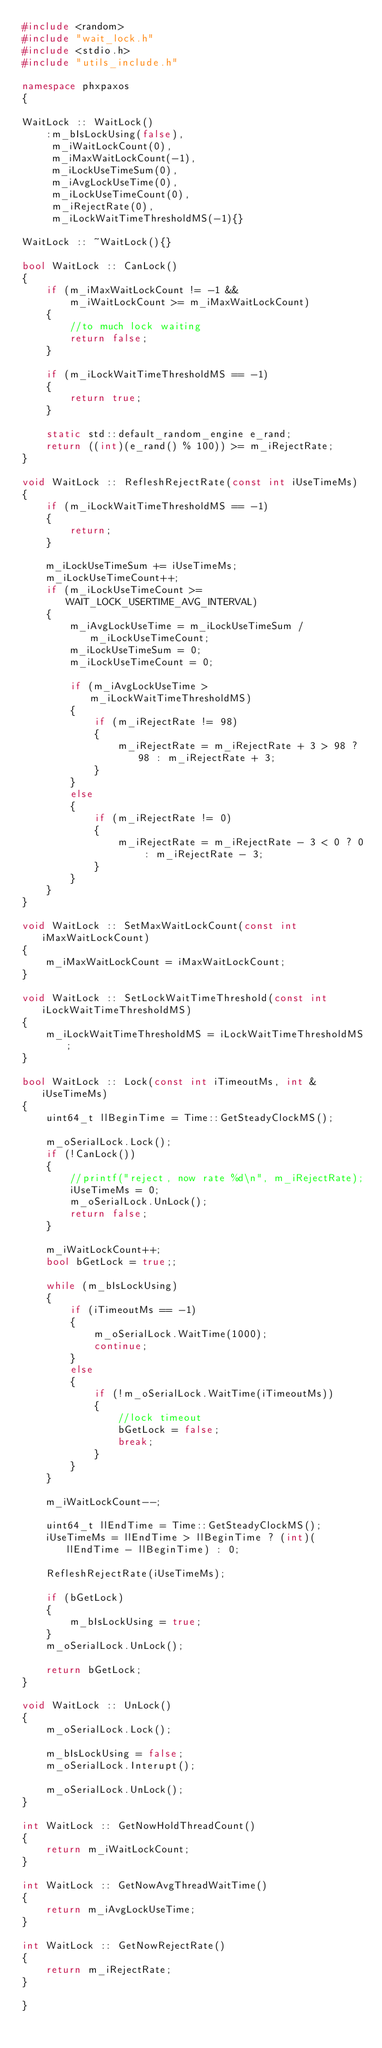Convert code to text. <code><loc_0><loc_0><loc_500><loc_500><_C++_>#include <random>
#include "wait_lock.h"
#include <stdio.h>
#include "utils_include.h"

namespace phxpaxos
{

WaitLock :: WaitLock() 
    :m_bIsLockUsing(false),
     m_iWaitLockCount(0),
     m_iMaxWaitLockCount(-1),
     m_iLockUseTimeSum(0),
     m_iAvgLockUseTime(0),
     m_iLockUseTimeCount(0),
     m_iRejectRate(0),
     m_iLockWaitTimeThresholdMS(-1){}

WaitLock :: ~WaitLock(){}

bool WaitLock :: CanLock()
{
    if (m_iMaxWaitLockCount != -1 &&
        m_iWaitLockCount >= m_iMaxWaitLockCount) 
    {
        //to much lock waiting
        return false;
    }

    if (m_iLockWaitTimeThresholdMS == -1)
    {
        return true;
    }

    static std::default_random_engine e_rand;
    return ((int)(e_rand() % 100)) >= m_iRejectRate;
}

void WaitLock :: RefleshRejectRate(const int iUseTimeMs)
{
    if (m_iLockWaitTimeThresholdMS == -1)
    {
        return;
    }

    m_iLockUseTimeSum += iUseTimeMs;
    m_iLockUseTimeCount++;
    if (m_iLockUseTimeCount >= WAIT_LOCK_USERTIME_AVG_INTERVAL)
    {
        m_iAvgLockUseTime = m_iLockUseTimeSum / m_iLockUseTimeCount;
        m_iLockUseTimeSum = 0;
        m_iLockUseTimeCount = 0;

        if (m_iAvgLockUseTime > m_iLockWaitTimeThresholdMS)
        {
            if (m_iRejectRate != 98)
            {
                m_iRejectRate = m_iRejectRate + 3 > 98 ? 98 : m_iRejectRate + 3;
            }
        }
        else
        {
            if (m_iRejectRate != 0)
            {
                m_iRejectRate = m_iRejectRate - 3 < 0 ? 0 : m_iRejectRate - 3;
            }
        }
    }
}

void WaitLock :: SetMaxWaitLockCount(const int iMaxWaitLockCount)
{
    m_iMaxWaitLockCount = iMaxWaitLockCount;
}

void WaitLock :: SetLockWaitTimeThreshold(const int iLockWaitTimeThresholdMS)
{
    m_iLockWaitTimeThresholdMS = iLockWaitTimeThresholdMS;
}

bool WaitLock :: Lock(const int iTimeoutMs, int & iUseTimeMs)
{
    uint64_t llBeginTime = Time::GetSteadyClockMS();

    m_oSerialLock.Lock();
    if (!CanLock())
    {
        //printf("reject, now rate %d\n", m_iRejectRate);
        iUseTimeMs = 0;
        m_oSerialLock.UnLock();
        return false;
    }

    m_iWaitLockCount++;
    bool bGetLock = true;;

    while (m_bIsLockUsing)
    {
        if (iTimeoutMs == -1)
        {
            m_oSerialLock.WaitTime(1000);
            continue;
        }
        else
        {
            if (!m_oSerialLock.WaitTime(iTimeoutMs))
            {
                //lock timeout
                bGetLock = false;
                break;
            }
        }
    }

    m_iWaitLockCount--;

    uint64_t llEndTime = Time::GetSteadyClockMS();
    iUseTimeMs = llEndTime > llBeginTime ? (int)(llEndTime - llBeginTime) : 0;

    RefleshRejectRate(iUseTimeMs);

    if (bGetLock)
    {
        m_bIsLockUsing = true;
    }
    m_oSerialLock.UnLock();

    return bGetLock;
}

void WaitLock :: UnLock()
{
    m_oSerialLock.Lock();

    m_bIsLockUsing = false;
    m_oSerialLock.Interupt();

    m_oSerialLock.UnLock();
}

int WaitLock :: GetNowHoldThreadCount()
{
    return m_iWaitLockCount;
}

int WaitLock :: GetNowAvgThreadWaitTime()
{
    return m_iAvgLockUseTime;
}

int WaitLock :: GetNowRejectRate()
{
    return m_iRejectRate;
}

}
</code> 